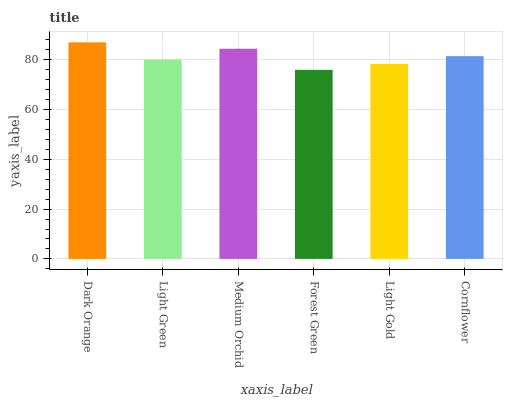Is Light Green the minimum?
Answer yes or no. No. Is Light Green the maximum?
Answer yes or no. No. Is Dark Orange greater than Light Green?
Answer yes or no. Yes. Is Light Green less than Dark Orange?
Answer yes or no. Yes. Is Light Green greater than Dark Orange?
Answer yes or no. No. Is Dark Orange less than Light Green?
Answer yes or no. No. Is Cornflower the high median?
Answer yes or no. Yes. Is Light Green the low median?
Answer yes or no. Yes. Is Forest Green the high median?
Answer yes or no. No. Is Cornflower the low median?
Answer yes or no. No. 